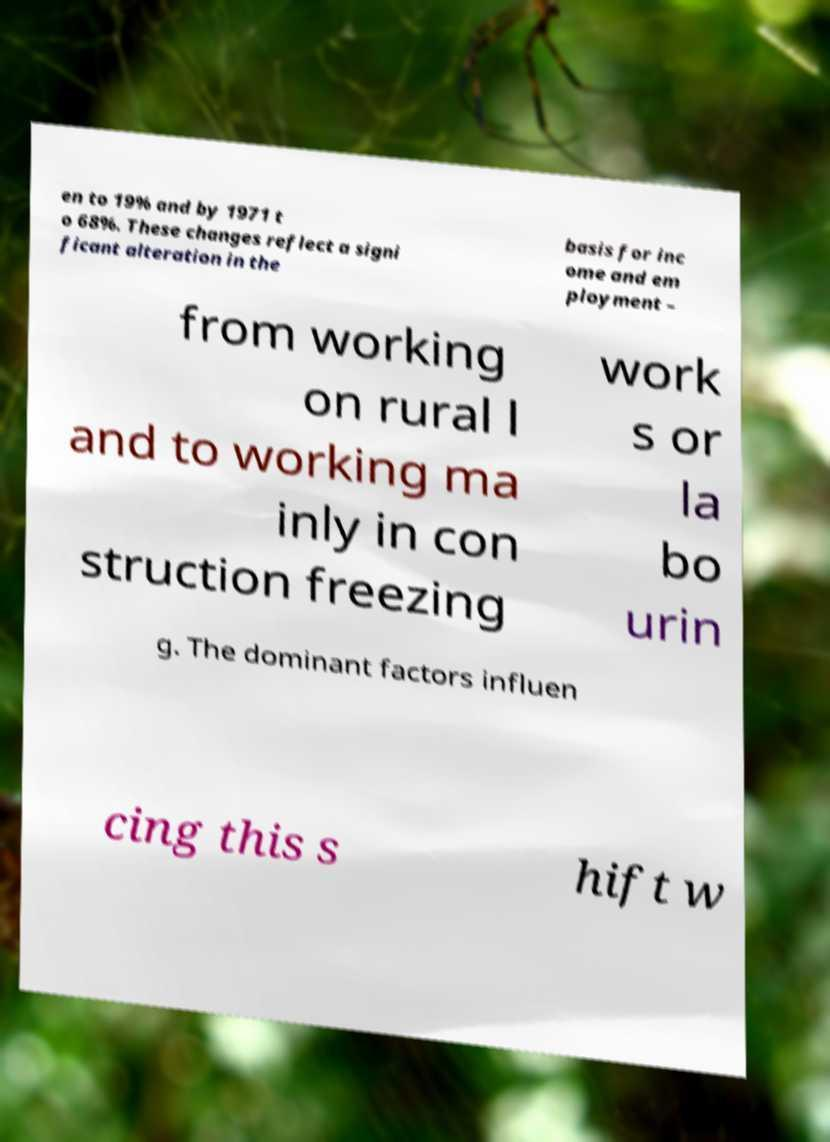Please read and relay the text visible in this image. What does it say? en to 19% and by 1971 t o 68%. These changes reflect a signi ficant alteration in the basis for inc ome and em ployment – from working on rural l and to working ma inly in con struction freezing work s or la bo urin g. The dominant factors influen cing this s hift w 